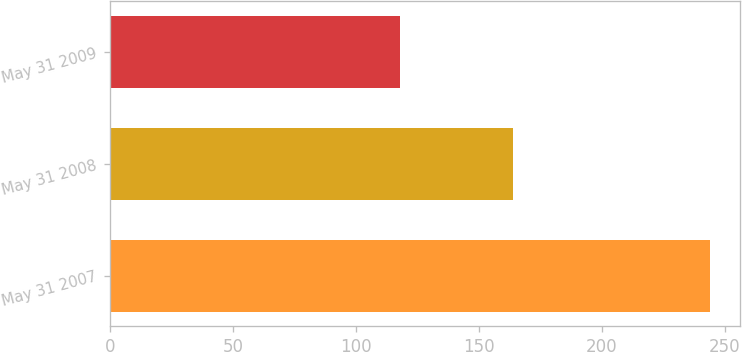Convert chart. <chart><loc_0><loc_0><loc_500><loc_500><bar_chart><fcel>May 31 2007<fcel>May 31 2008<fcel>May 31 2009<nl><fcel>244<fcel>164<fcel>118<nl></chart> 